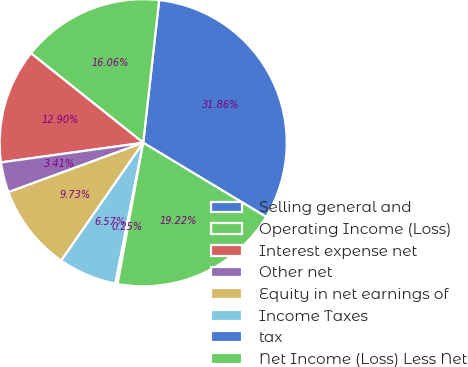Convert chart to OTSL. <chart><loc_0><loc_0><loc_500><loc_500><pie_chart><fcel>Selling general and<fcel>Operating Income (Loss)<fcel>Interest expense net<fcel>Other net<fcel>Equity in net earnings of<fcel>Income Taxes<fcel>tax<fcel>Net Income (Loss) Less Net<nl><fcel>31.86%<fcel>16.06%<fcel>12.9%<fcel>3.41%<fcel>9.73%<fcel>6.57%<fcel>0.25%<fcel>19.22%<nl></chart> 